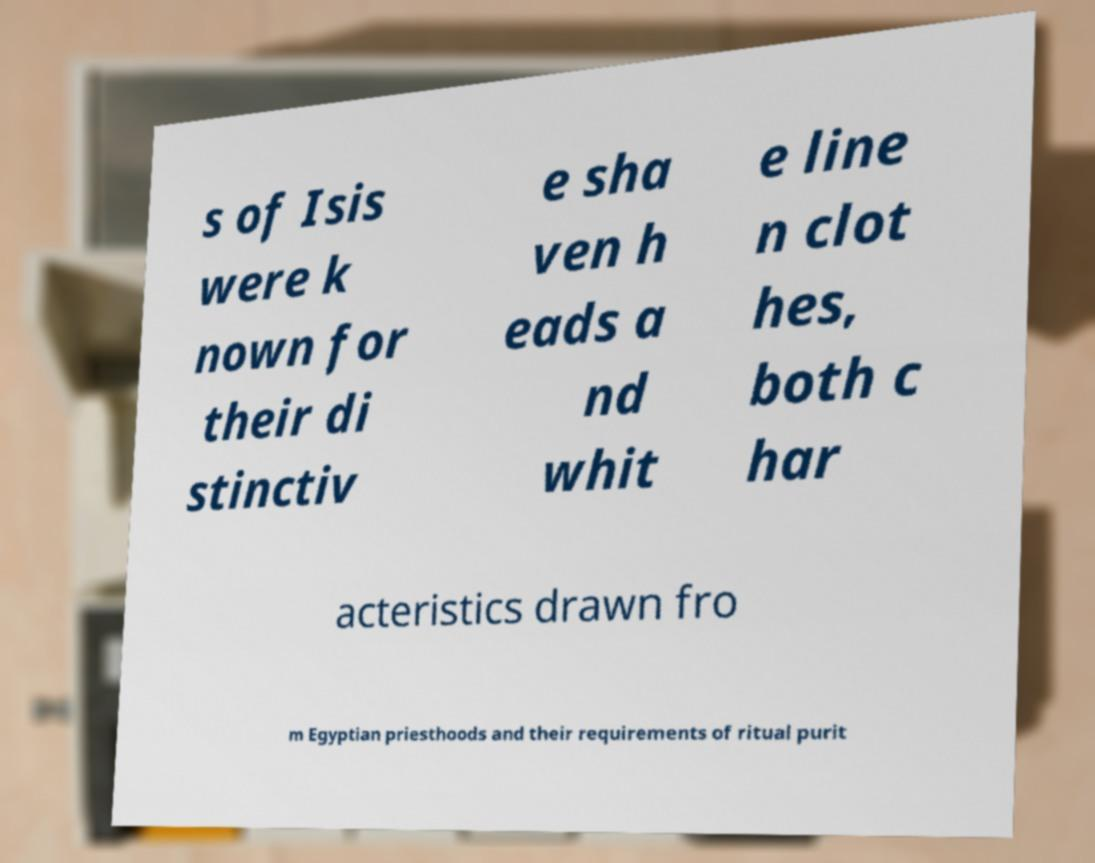For documentation purposes, I need the text within this image transcribed. Could you provide that? s of Isis were k nown for their di stinctiv e sha ven h eads a nd whit e line n clot hes, both c har acteristics drawn fro m Egyptian priesthoods and their requirements of ritual purit 